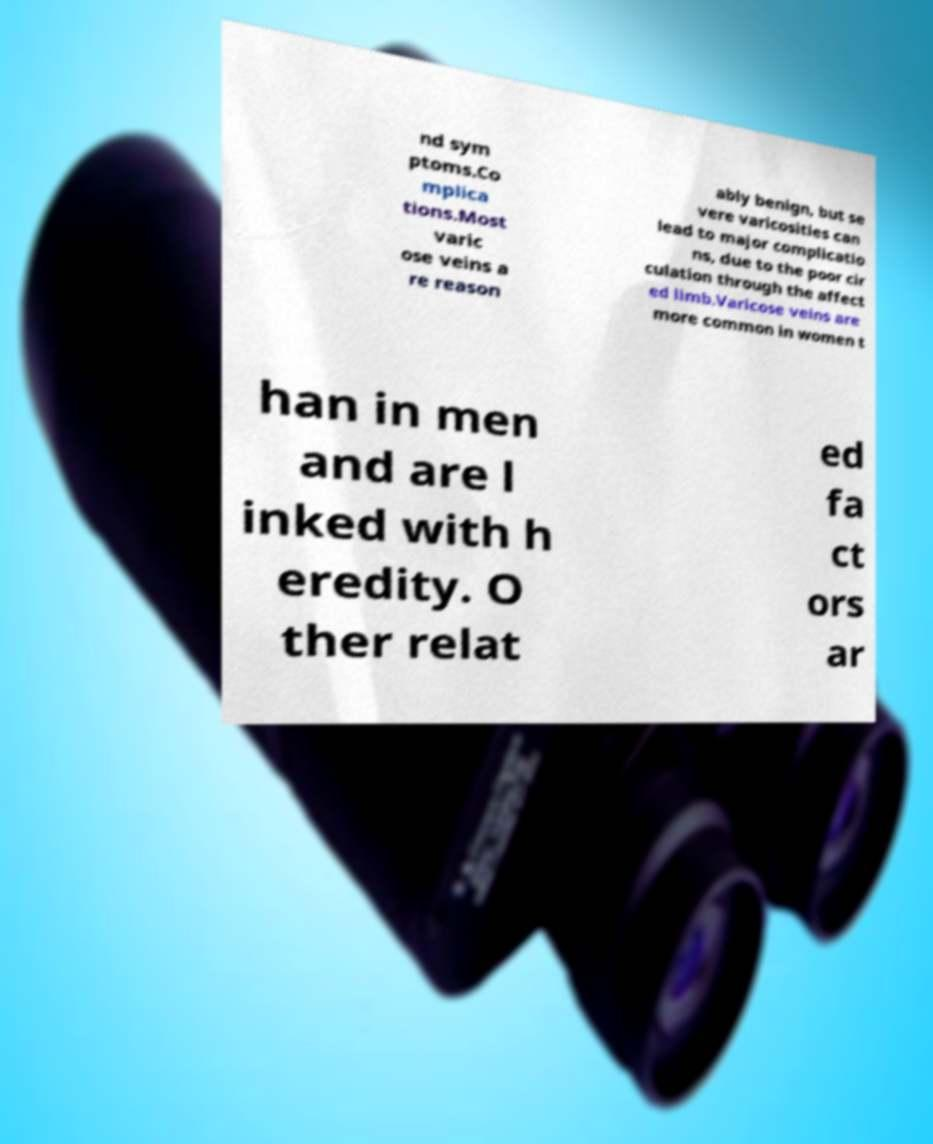Can you accurately transcribe the text from the provided image for me? nd sym ptoms.Co mplica tions.Most varic ose veins a re reason ably benign, but se vere varicosities can lead to major complicatio ns, due to the poor cir culation through the affect ed limb.Varicose veins are more common in women t han in men and are l inked with h eredity. O ther relat ed fa ct ors ar 